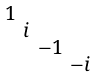Convert formula to latex. <formula><loc_0><loc_0><loc_500><loc_500>\begin{smallmatrix} 1 & & & \\ & i & & \\ & & - 1 & \\ & & & - i \end{smallmatrix}</formula> 